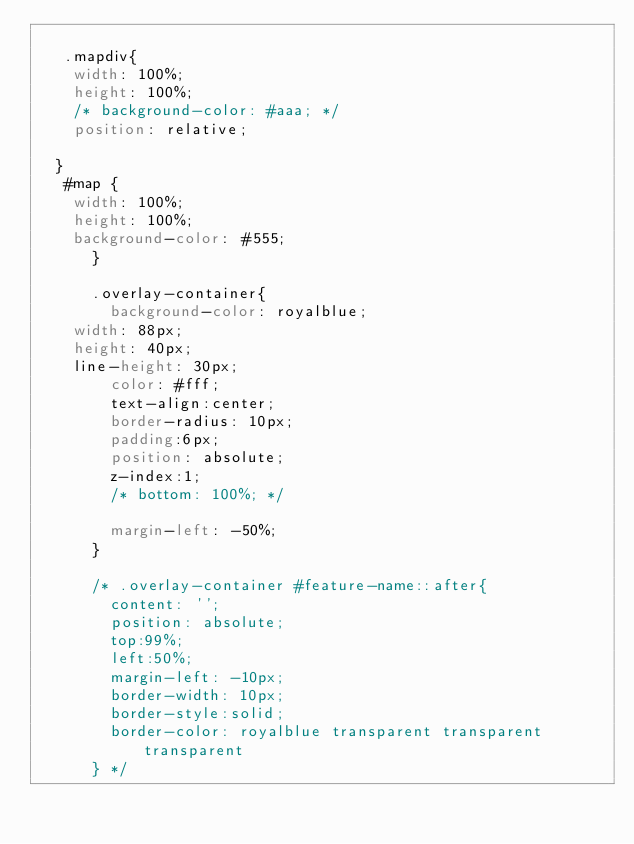<code> <loc_0><loc_0><loc_500><loc_500><_CSS_>	  
	 .mapdiv{
		width: 100%;
		height: 100%;
		/* background-color: #aaa; */
		position: relative;

	}
	 #map {
		width: 100%;
		height: 100%;
		background-color: #555;
      }

      .overlay-container{
      	background-color: royalblue;
		width: 88px;
		height: 40px;
		line-height: 30px;
      	color: #fff;
      	text-align:center;
      	border-radius: 10px;
      	padding:6px;
      	position: absolute;
      	z-index:1;
      	/* bottom: 100%; */
	
      	margin-left: -50%;
      }

      /* .overlay-container #feature-name::after{
      	content: '';
      	position: absolute;
      	top:99%;
      	left:50%;
      	margin-left: -10px;
      	border-width: 10px;
      	border-style:solid;
      	border-color: royalblue transparent transparent transparent
      } */</code> 